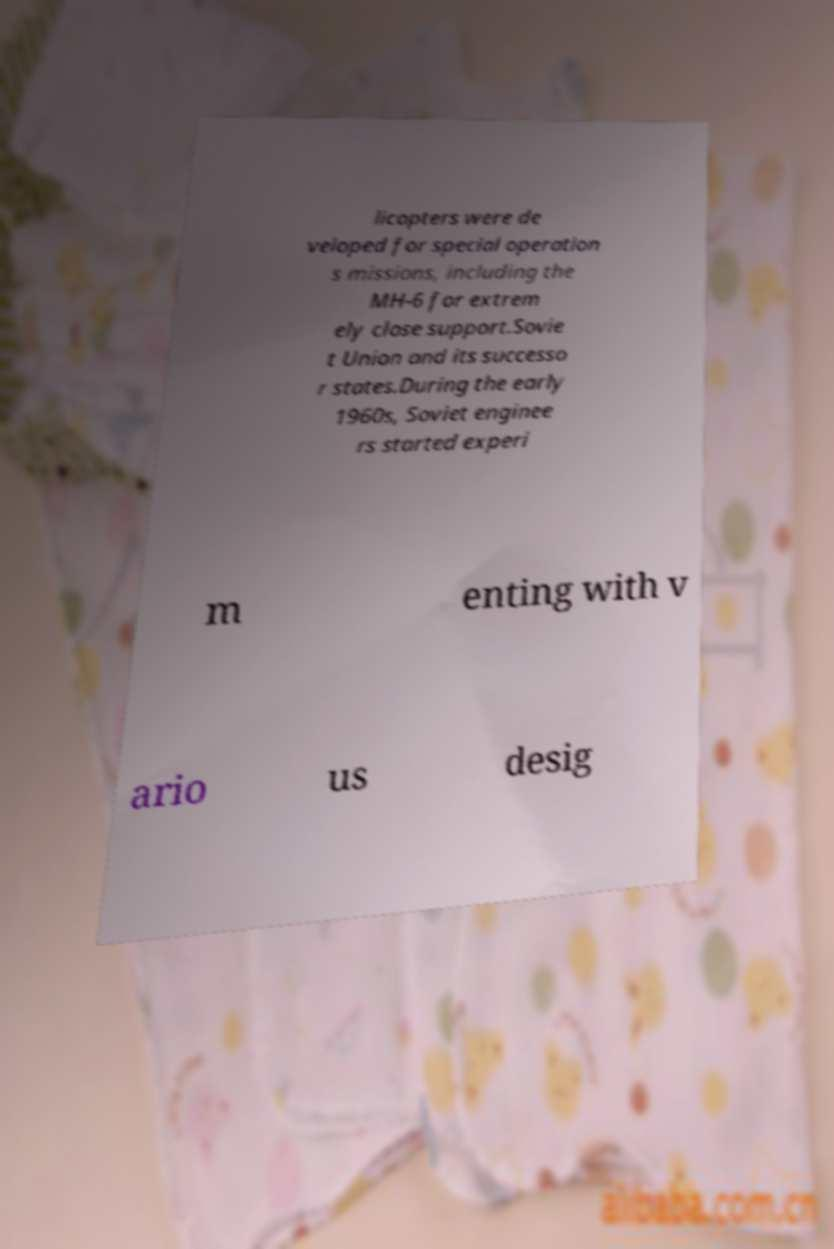Can you read and provide the text displayed in the image?This photo seems to have some interesting text. Can you extract and type it out for me? licopters were de veloped for special operation s missions, including the MH-6 for extrem ely close support.Sovie t Union and its successo r states.During the early 1960s, Soviet enginee rs started experi m enting with v ario us desig 